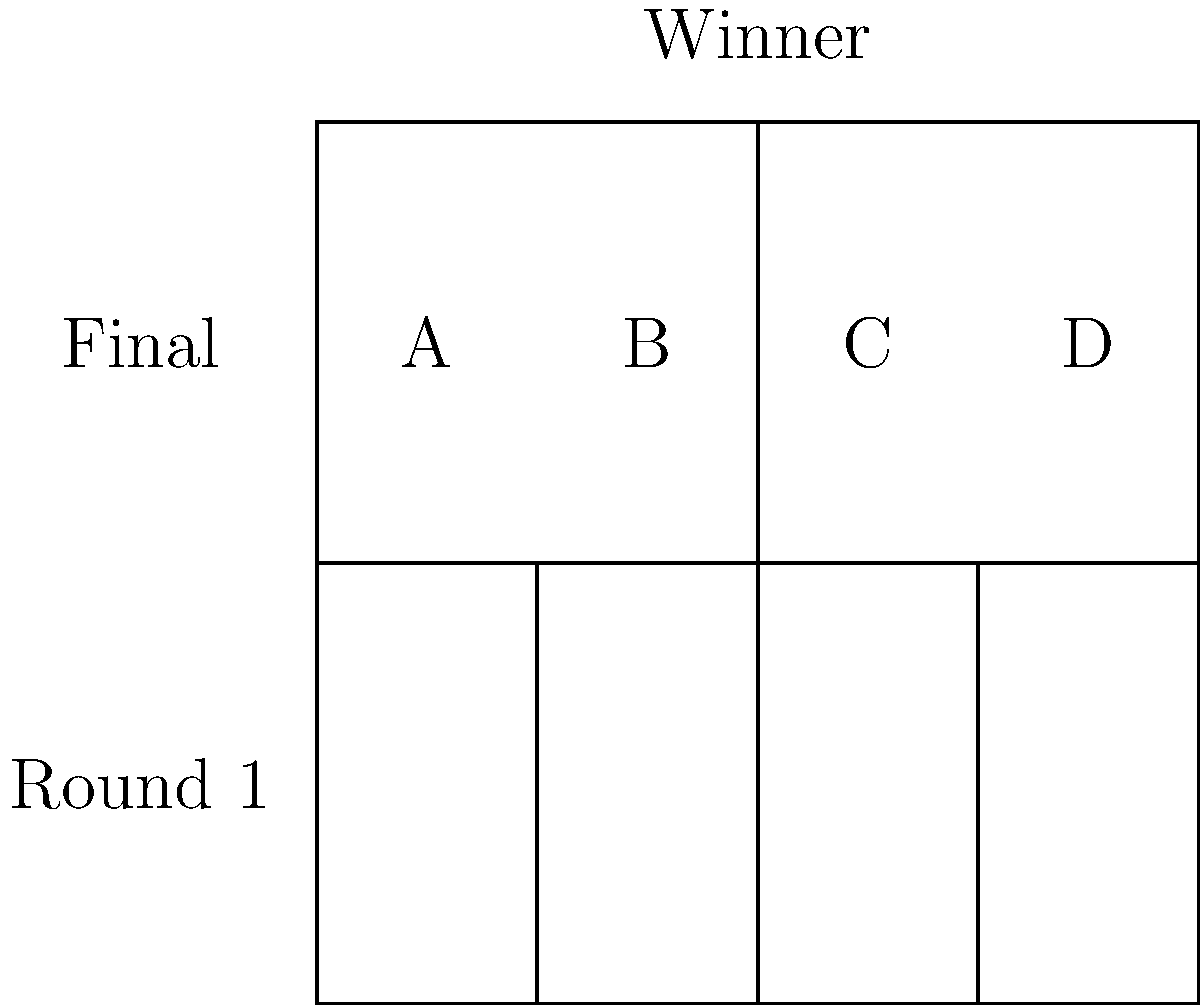In a four-team tournament bracket as shown, how many distinct outcomes are possible if we consider the order of elimination important? Express your answer in terms of group theory operations. To solve this problem using group theory, we'll follow these steps:

1) First, let's consider the structure of the tournament:
   - There are two semifinal matches (A vs B, C vs D)
   - The winners of these matches face each other in the final

2) For each match, there are two possible outcomes. This suggests we can use the cyclic group of order 2, $C_2$, to represent each match.

3) The entire tournament can be represented as a combination of these $C_2$ groups:
   - Two $C_2$ groups for the semifinals
   - One $C_2$ group for the final

4) In group theory, when we combine groups like this, we use the direct product operation. So our tournament group is:

   $G = C_2 \times C_2 \times C_2$

5) To find the number of distinct outcomes, we need to calculate the order of this group. In group theory, the order of a direct product is the product of the orders of its component groups:

   $|G| = |C_2| \times |C_2| \times |C_2| = 2 \times 2 \times 2 = 8$

6) Therefore, there are 8 distinct outcomes when considering the order of elimination.

These outcomes correspond to all possible combinations of winners in each round, which also determines the order of elimination.
Answer: $|C_2 \times C_2 \times C_2| = 8$ 